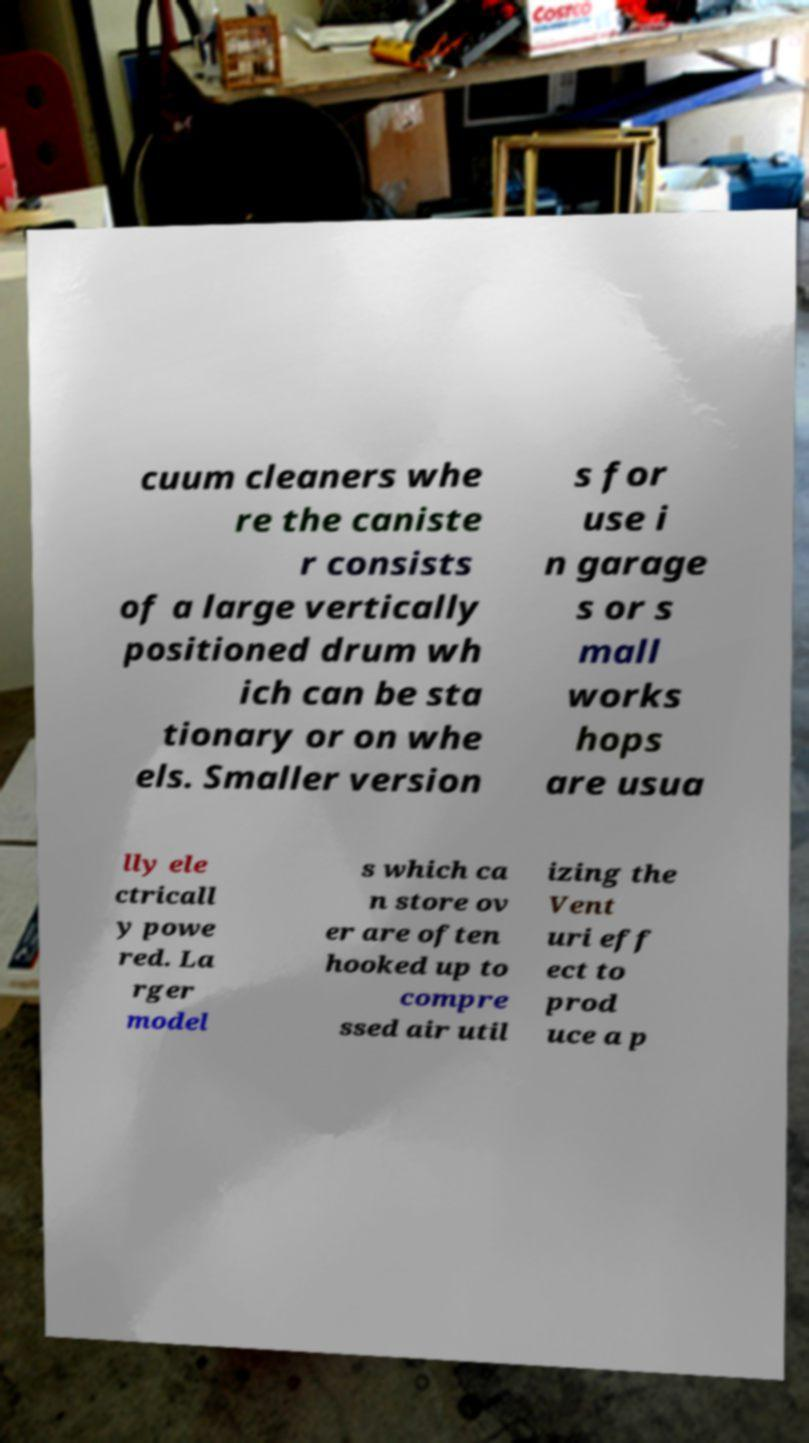What messages or text are displayed in this image? I need them in a readable, typed format. cuum cleaners whe re the caniste r consists of a large vertically positioned drum wh ich can be sta tionary or on whe els. Smaller version s for use i n garage s or s mall works hops are usua lly ele ctricall y powe red. La rger model s which ca n store ov er are often hooked up to compre ssed air util izing the Vent uri eff ect to prod uce a p 